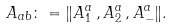<formula> <loc_0><loc_0><loc_500><loc_500>A _ { a b } \colon = \| A ^ { a } _ { 1 } \, , A ^ { a } _ { 2 } \, , A ^ { a } _ { - } \| .</formula> 